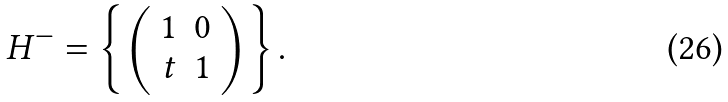<formula> <loc_0><loc_0><loc_500><loc_500>H ^ { - } = \left \{ \left ( \begin{array} { c c } 1 & 0 \\ t & 1 \end{array} \right ) \right \} .</formula> 